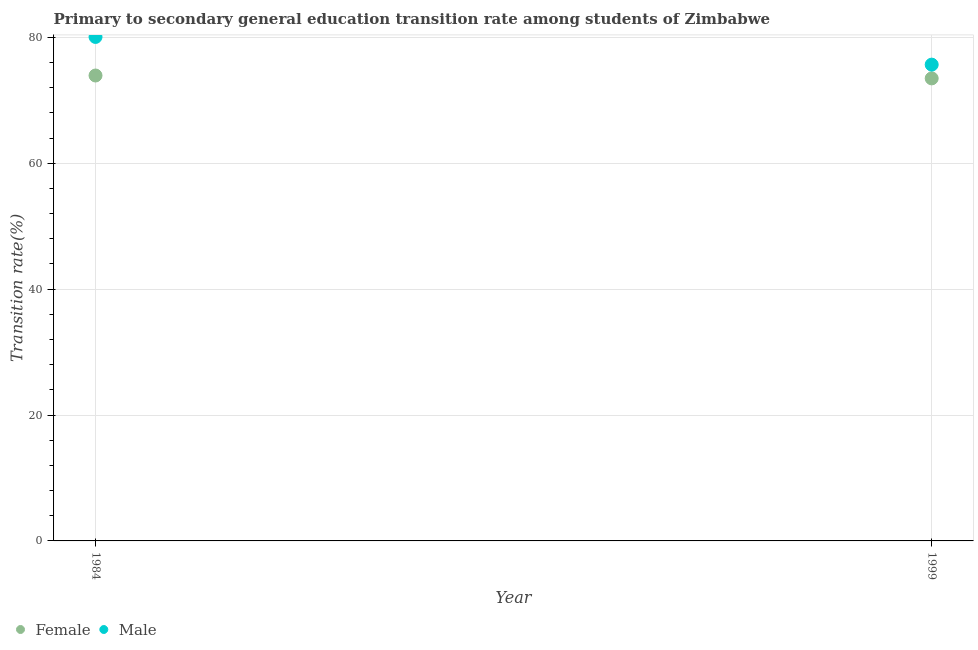How many different coloured dotlines are there?
Your response must be concise. 2. Is the number of dotlines equal to the number of legend labels?
Your response must be concise. Yes. What is the transition rate among male students in 1999?
Make the answer very short. 75.66. Across all years, what is the maximum transition rate among female students?
Provide a short and direct response. 73.93. Across all years, what is the minimum transition rate among female students?
Make the answer very short. 73.48. In which year was the transition rate among male students minimum?
Provide a short and direct response. 1999. What is the total transition rate among male students in the graph?
Provide a succinct answer. 155.72. What is the difference between the transition rate among male students in 1984 and that in 1999?
Your answer should be very brief. 4.4. What is the difference between the transition rate among male students in 1999 and the transition rate among female students in 1984?
Offer a terse response. 1.73. What is the average transition rate among male students per year?
Your answer should be very brief. 77.86. In the year 1999, what is the difference between the transition rate among female students and transition rate among male students?
Offer a terse response. -2.18. In how many years, is the transition rate among male students greater than 20 %?
Offer a terse response. 2. What is the ratio of the transition rate among female students in 1984 to that in 1999?
Your answer should be very brief. 1.01. In how many years, is the transition rate among male students greater than the average transition rate among male students taken over all years?
Your answer should be compact. 1. Is the transition rate among male students strictly less than the transition rate among female students over the years?
Your response must be concise. No. Are the values on the major ticks of Y-axis written in scientific E-notation?
Your answer should be very brief. No. Where does the legend appear in the graph?
Offer a terse response. Bottom left. How are the legend labels stacked?
Your response must be concise. Horizontal. What is the title of the graph?
Give a very brief answer. Primary to secondary general education transition rate among students of Zimbabwe. Does "Age 15+" appear as one of the legend labels in the graph?
Your answer should be very brief. No. What is the label or title of the X-axis?
Give a very brief answer. Year. What is the label or title of the Y-axis?
Make the answer very short. Transition rate(%). What is the Transition rate(%) of Female in 1984?
Offer a terse response. 73.93. What is the Transition rate(%) in Male in 1984?
Your answer should be very brief. 80.06. What is the Transition rate(%) in Female in 1999?
Your answer should be very brief. 73.48. What is the Transition rate(%) of Male in 1999?
Keep it short and to the point. 75.66. Across all years, what is the maximum Transition rate(%) in Female?
Your answer should be compact. 73.93. Across all years, what is the maximum Transition rate(%) in Male?
Make the answer very short. 80.06. Across all years, what is the minimum Transition rate(%) of Female?
Provide a succinct answer. 73.48. Across all years, what is the minimum Transition rate(%) of Male?
Offer a terse response. 75.66. What is the total Transition rate(%) of Female in the graph?
Your answer should be compact. 147.41. What is the total Transition rate(%) in Male in the graph?
Offer a very short reply. 155.72. What is the difference between the Transition rate(%) in Female in 1984 and that in 1999?
Your response must be concise. 0.46. What is the difference between the Transition rate(%) of Male in 1984 and that in 1999?
Provide a succinct answer. 4.4. What is the difference between the Transition rate(%) in Female in 1984 and the Transition rate(%) in Male in 1999?
Your response must be concise. -1.73. What is the average Transition rate(%) in Female per year?
Ensure brevity in your answer.  73.7. What is the average Transition rate(%) in Male per year?
Provide a short and direct response. 77.86. In the year 1984, what is the difference between the Transition rate(%) of Female and Transition rate(%) of Male?
Provide a succinct answer. -6.13. In the year 1999, what is the difference between the Transition rate(%) in Female and Transition rate(%) in Male?
Your answer should be compact. -2.18. What is the ratio of the Transition rate(%) in Male in 1984 to that in 1999?
Your response must be concise. 1.06. What is the difference between the highest and the second highest Transition rate(%) of Female?
Give a very brief answer. 0.46. What is the difference between the highest and the second highest Transition rate(%) of Male?
Your answer should be compact. 4.4. What is the difference between the highest and the lowest Transition rate(%) of Female?
Offer a terse response. 0.46. What is the difference between the highest and the lowest Transition rate(%) of Male?
Keep it short and to the point. 4.4. 